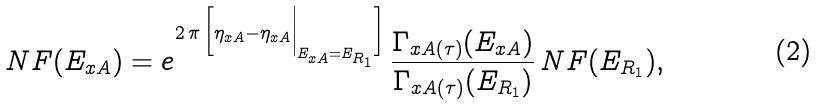Convert formula to latex. <formula><loc_0><loc_0><loc_500><loc_500>N F ( E _ { x A } ) = e ^ { 2 \, \pi \, \Big [ \eta _ { x A } - \eta _ { x A } \Big | _ { E _ { x A } = E _ { R _ { 1 } } } \Big ] } \, \frac { \Gamma _ { x A ( \tau ) } ( E _ { x A } ) } { \Gamma _ { x A ( \tau ) } ( E _ { R _ { 1 } } ) } \, N F ( E _ { R _ { 1 } } ) ,</formula> 